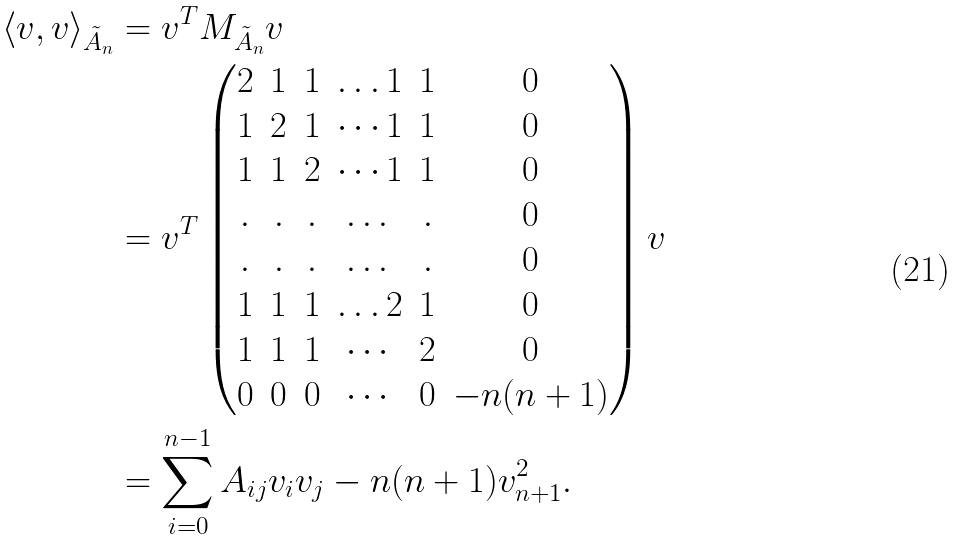<formula> <loc_0><loc_0><loc_500><loc_500>\langle v , v \rangle _ { \tilde { A } _ { n } } & = v ^ { T } M _ { \tilde { A } _ { n } } v \\ & = v ^ { T } \begin{pmatrix} 2 & 1 & 1 & \dots 1 & 1 & 0 \\ 1 & 2 & 1 & \cdots 1 & 1 & 0 \\ 1 & 1 & 2 & \cdots 1 & 1 & 0 \\ . & . & . & \dots & . & 0 \\ . & . & . & \dots & . & 0 \\ 1 & 1 & 1 & \dots 2 & 1 & 0 \\ 1 & 1 & 1 & \cdots & 2 & 0 \\ 0 & 0 & 0 & \cdots & 0 & - n ( n + 1 ) \\ \end{pmatrix} v \\ & = \sum _ { i = 0 } ^ { n - 1 } A _ { i j } v _ { i } v _ { j } - n ( n + 1 ) v _ { n + 1 } ^ { 2 } .</formula> 